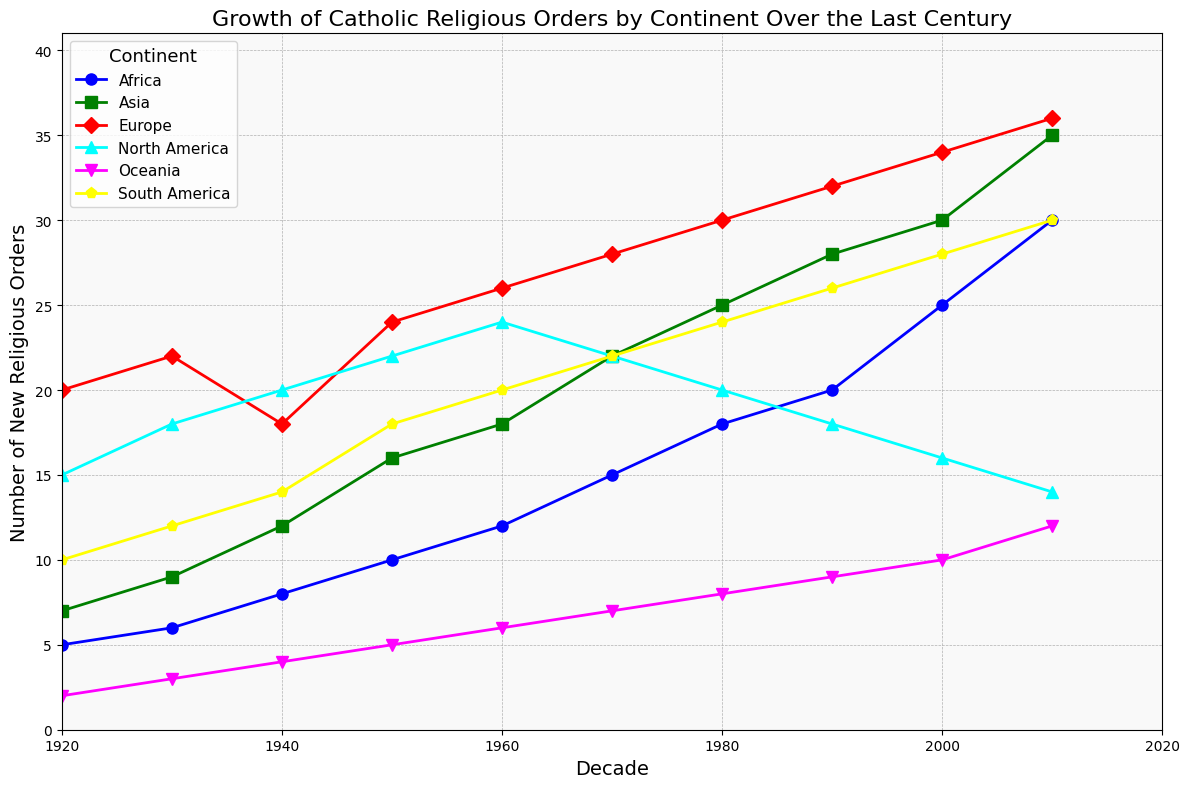What is the average number of new religious orders founded in Africa between the 1920s and the 1980s? Sum the number of new religious orders founded in Africa from the 1920s to the 1980s: 5 + 6 + 8 + 10 + 12 + 15 + 18. Then, divide by the number of decades (7): (5 + 6 + 8 + 10 + 12 + 15 + 18) / 7 = 74 / 7 ≈ 10.57
Answer: 10.57 Which continent showed the highest growth in new religious orders from the 1920s to the 2010s? Compare the increase in the number of new religious orders from the 1920s to the 2010s for each continent: Africa (30 - 5 = 25), Asia (35 - 7 = 28), Europe (36 - 20 = 16), North America (14 - 15 = -1), South America (30 - 10 = 20), Oceania (12 - 2 = 10). The highest growth is in Asia with an increase of 28
Answer: Asia In which decade did Europe see the highest number of new religious orders founded? Review the values for Europe across all decades and identify the highest: 1920s (20), 1930s (22), 1940s (18), 1950s (24), 1960s (26), 1970s (28), 1980s (30), 1990s (32), 2000s (34), 2010s (36). The highest is in the 2010s with 36 new religious orders
Answer: 2010s How many new religious orders were founded in North America during the 1940s? Locate the value corresponding to North America in the 1940s: 20
Answer: 20 What is the difference between the number of new religious orders founded in South America and North America in the 2010s? Subtract the number of new religious orders in North America in the 2010s from that in South America in the same decade: 30 - 14 = 16
Answer: 16 Which continent had the lowest number of new religious orders founded in the 1920s? Identify the lowest value among the continents for the 1920s: Africa (5), Asia (7), Europe (20), North America (15), South America (10), Oceania (2). The lowest is Oceania with 2 new religious orders
Answer: Oceania By how much did the number of new religious orders in Africa increase from the 1980s to the 2010s? Subtract the number of new religious orders in Africa in the 1980s from that in the 2010s: 30 - 18 = 12
Answer: 12 In which decade did North America start to see a decline in the number of new religious orders? Assess the figures for North America across the decades and identify the point at which the numbers begin to decrease: 1920s (15), 1930s (18), 1940s (20), 1950s (22), 1960s (24), 1970s (22), 1980s (20), 1990s (18), 2000s (16), 2010s (14). The decline starts in the 1970s
Answer: 1970s Which continent had the most consistent growth in the number of new religious orders over the past century? Examine the numerical trends for each continent: Africa (consistent increase), Asia (consistent increase), Europe (consistent increase), North America (growth then decline), South America (consistent increase), Oceania (consistent increase). Most continents show consistent growth, but Africa has a slightly smoother trend
Answer: Africa 